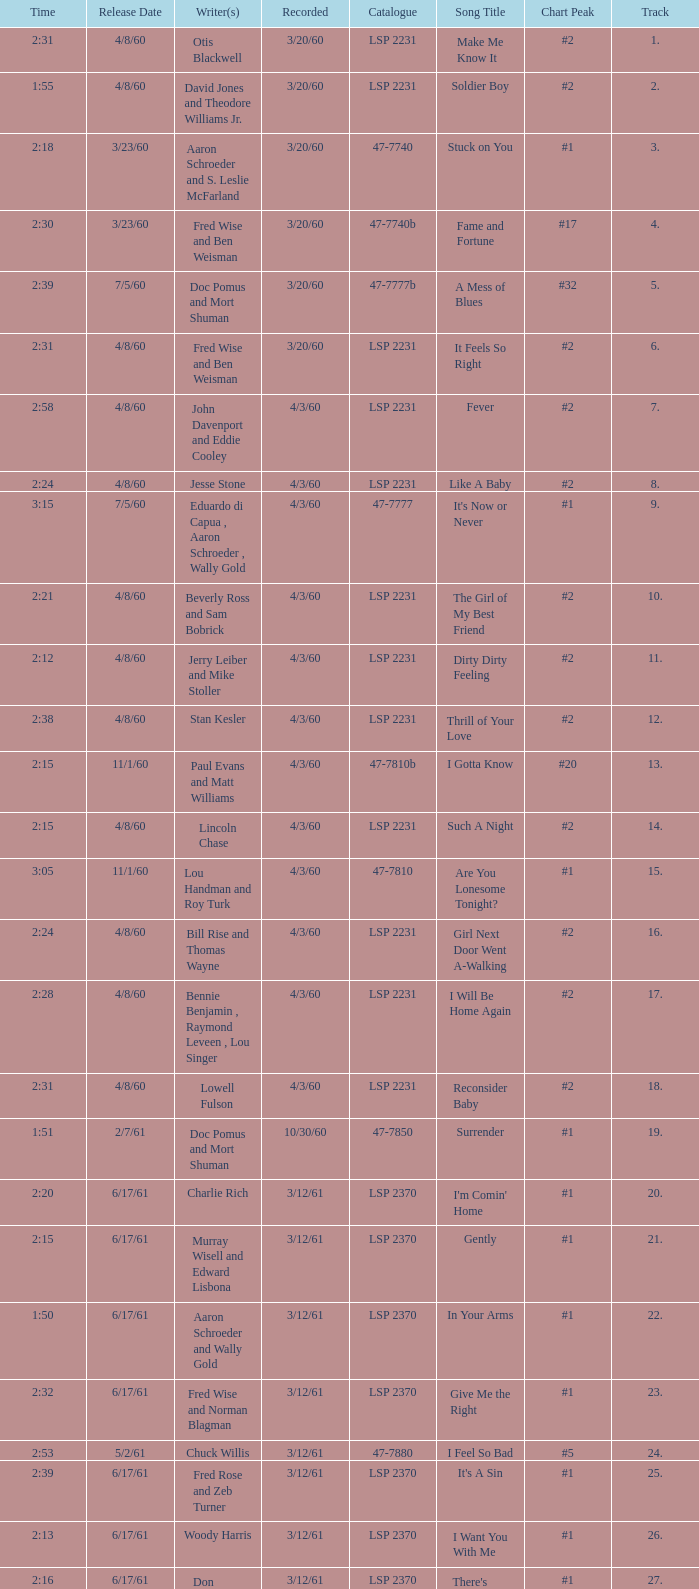On songs with track numbers smaller than number 17 and catalogues of LSP 2231, who are the writer(s)? Otis Blackwell, David Jones and Theodore Williams Jr., Fred Wise and Ben Weisman, John Davenport and Eddie Cooley, Jesse Stone, Beverly Ross and Sam Bobrick, Jerry Leiber and Mike Stoller, Stan Kesler, Lincoln Chase, Bill Rise and Thomas Wayne. 